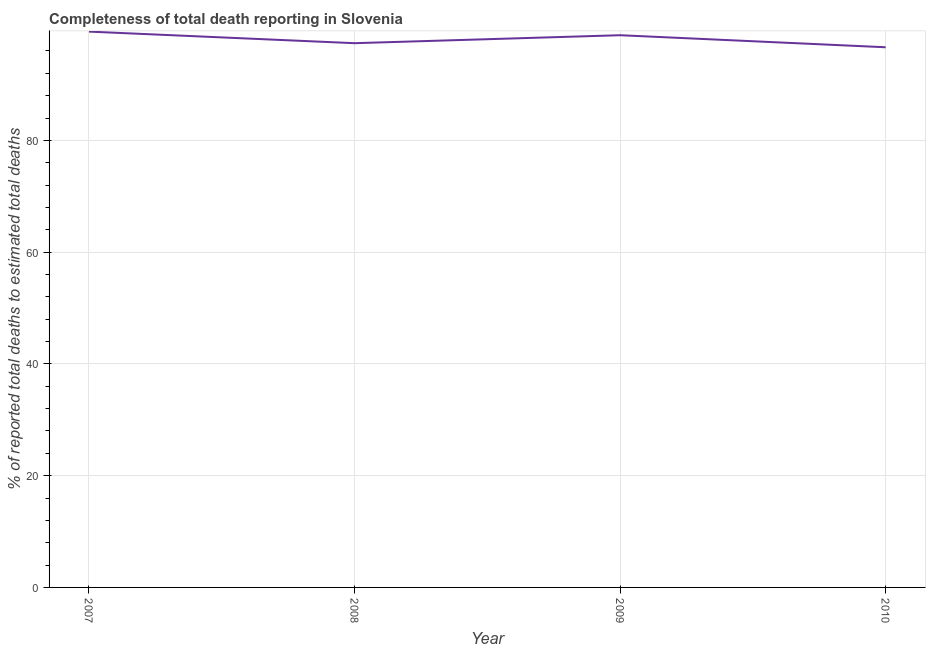What is the completeness of total death reports in 2008?
Your answer should be compact. 97.39. Across all years, what is the maximum completeness of total death reports?
Your answer should be very brief. 99.46. Across all years, what is the minimum completeness of total death reports?
Your response must be concise. 96.66. In which year was the completeness of total death reports maximum?
Provide a succinct answer. 2007. In which year was the completeness of total death reports minimum?
Provide a succinct answer. 2010. What is the sum of the completeness of total death reports?
Your answer should be compact. 392.34. What is the difference between the completeness of total death reports in 2009 and 2010?
Offer a very short reply. 2.16. What is the average completeness of total death reports per year?
Your answer should be very brief. 98.09. What is the median completeness of total death reports?
Your answer should be very brief. 98.11. What is the ratio of the completeness of total death reports in 2007 to that in 2010?
Offer a very short reply. 1.03. What is the difference between the highest and the second highest completeness of total death reports?
Your answer should be very brief. 0.65. What is the difference between the highest and the lowest completeness of total death reports?
Your response must be concise. 2.8. In how many years, is the completeness of total death reports greater than the average completeness of total death reports taken over all years?
Make the answer very short. 2. Does the completeness of total death reports monotonically increase over the years?
Offer a very short reply. No. How many lines are there?
Provide a short and direct response. 1. How many years are there in the graph?
Make the answer very short. 4. Are the values on the major ticks of Y-axis written in scientific E-notation?
Your response must be concise. No. Does the graph contain grids?
Offer a terse response. Yes. What is the title of the graph?
Your answer should be very brief. Completeness of total death reporting in Slovenia. What is the label or title of the Y-axis?
Ensure brevity in your answer.  % of reported total deaths to estimated total deaths. What is the % of reported total deaths to estimated total deaths of 2007?
Offer a very short reply. 99.46. What is the % of reported total deaths to estimated total deaths of 2008?
Keep it short and to the point. 97.39. What is the % of reported total deaths to estimated total deaths of 2009?
Your answer should be very brief. 98.82. What is the % of reported total deaths to estimated total deaths in 2010?
Offer a very short reply. 96.66. What is the difference between the % of reported total deaths to estimated total deaths in 2007 and 2008?
Provide a succinct answer. 2.07. What is the difference between the % of reported total deaths to estimated total deaths in 2007 and 2009?
Offer a very short reply. 0.65. What is the difference between the % of reported total deaths to estimated total deaths in 2007 and 2010?
Your answer should be very brief. 2.8. What is the difference between the % of reported total deaths to estimated total deaths in 2008 and 2009?
Offer a terse response. -1.43. What is the difference between the % of reported total deaths to estimated total deaths in 2008 and 2010?
Offer a very short reply. 0.73. What is the difference between the % of reported total deaths to estimated total deaths in 2009 and 2010?
Provide a succinct answer. 2.16. What is the ratio of the % of reported total deaths to estimated total deaths in 2007 to that in 2008?
Offer a terse response. 1.02. What is the ratio of the % of reported total deaths to estimated total deaths in 2007 to that in 2009?
Offer a very short reply. 1.01. What is the ratio of the % of reported total deaths to estimated total deaths in 2008 to that in 2010?
Provide a short and direct response. 1.01. What is the ratio of the % of reported total deaths to estimated total deaths in 2009 to that in 2010?
Offer a terse response. 1.02. 